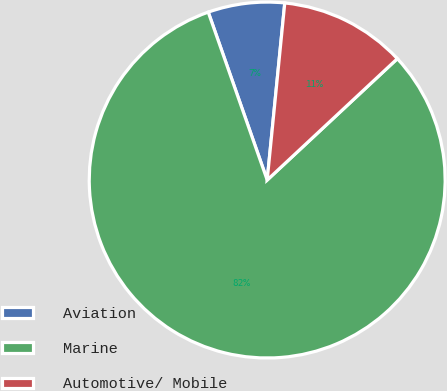Convert chart to OTSL. <chart><loc_0><loc_0><loc_500><loc_500><pie_chart><fcel>Aviation<fcel>Marine<fcel>Automotive/ Mobile<nl><fcel>6.95%<fcel>81.57%<fcel>11.48%<nl></chart> 